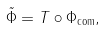<formula> <loc_0><loc_0><loc_500><loc_500>\tilde { \Phi } = T \circ \Phi _ { \text {com} } ,</formula> 